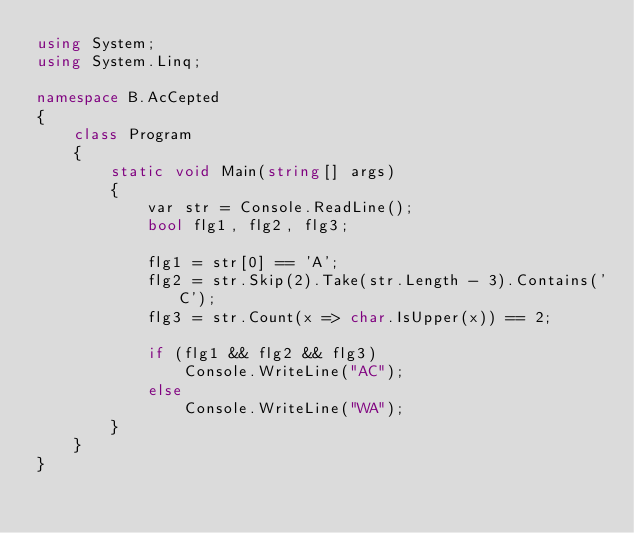Convert code to text. <code><loc_0><loc_0><loc_500><loc_500><_C#_>using System;
using System.Linq;

namespace B.AcCepted
{
    class Program
    {
        static void Main(string[] args)
        {
            var str = Console.ReadLine();
            bool flg1, flg2, flg3;

            flg1 = str[0] == 'A';
            flg2 = str.Skip(2).Take(str.Length - 3).Contains('C');
            flg3 = str.Count(x => char.IsUpper(x)) == 2;
            
            if (flg1 && flg2 && flg3)
                Console.WriteLine("AC");
            else
                Console.WriteLine("WA");
        }
    }
}</code> 